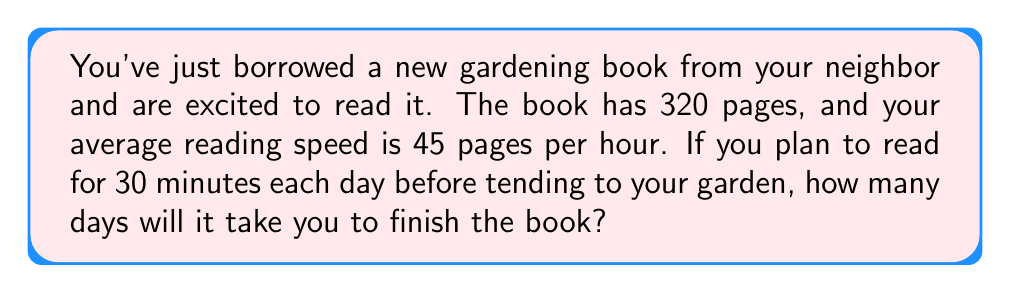Help me with this question. Let's break this problem down step-by-step:

1. Calculate your reading speed in pages per minute:
   $$ \text{Pages per minute} = \frac{45 \text{ pages/hour}}{60 \text{ minutes/hour}} = 0.75 \text{ pages/minute} $$

2. Calculate how many pages you can read in 30 minutes:
   $$ \text{Pages read in 30 minutes} = 0.75 \text{ pages/minute} \times 30 \text{ minutes} = 22.5 \text{ pages} $$

3. Calculate the number of 30-minute sessions needed to read the entire book:
   $$ \text{Number of sessions} = \frac{320 \text{ pages}}{22.5 \text{ pages/session}} = 14.22 \text{ sessions} $$

4. Since you can't have a partial reading session, we need to round up to the nearest whole number:
   $$ \text{Rounded number of sessions} = \lceil 14.22 \rceil = 15 \text{ sessions} $$

5. Since each session represents one day, the number of days required is equal to the number of sessions.

Therefore, it will take 15 days to finish the book.
Answer: 15 days 